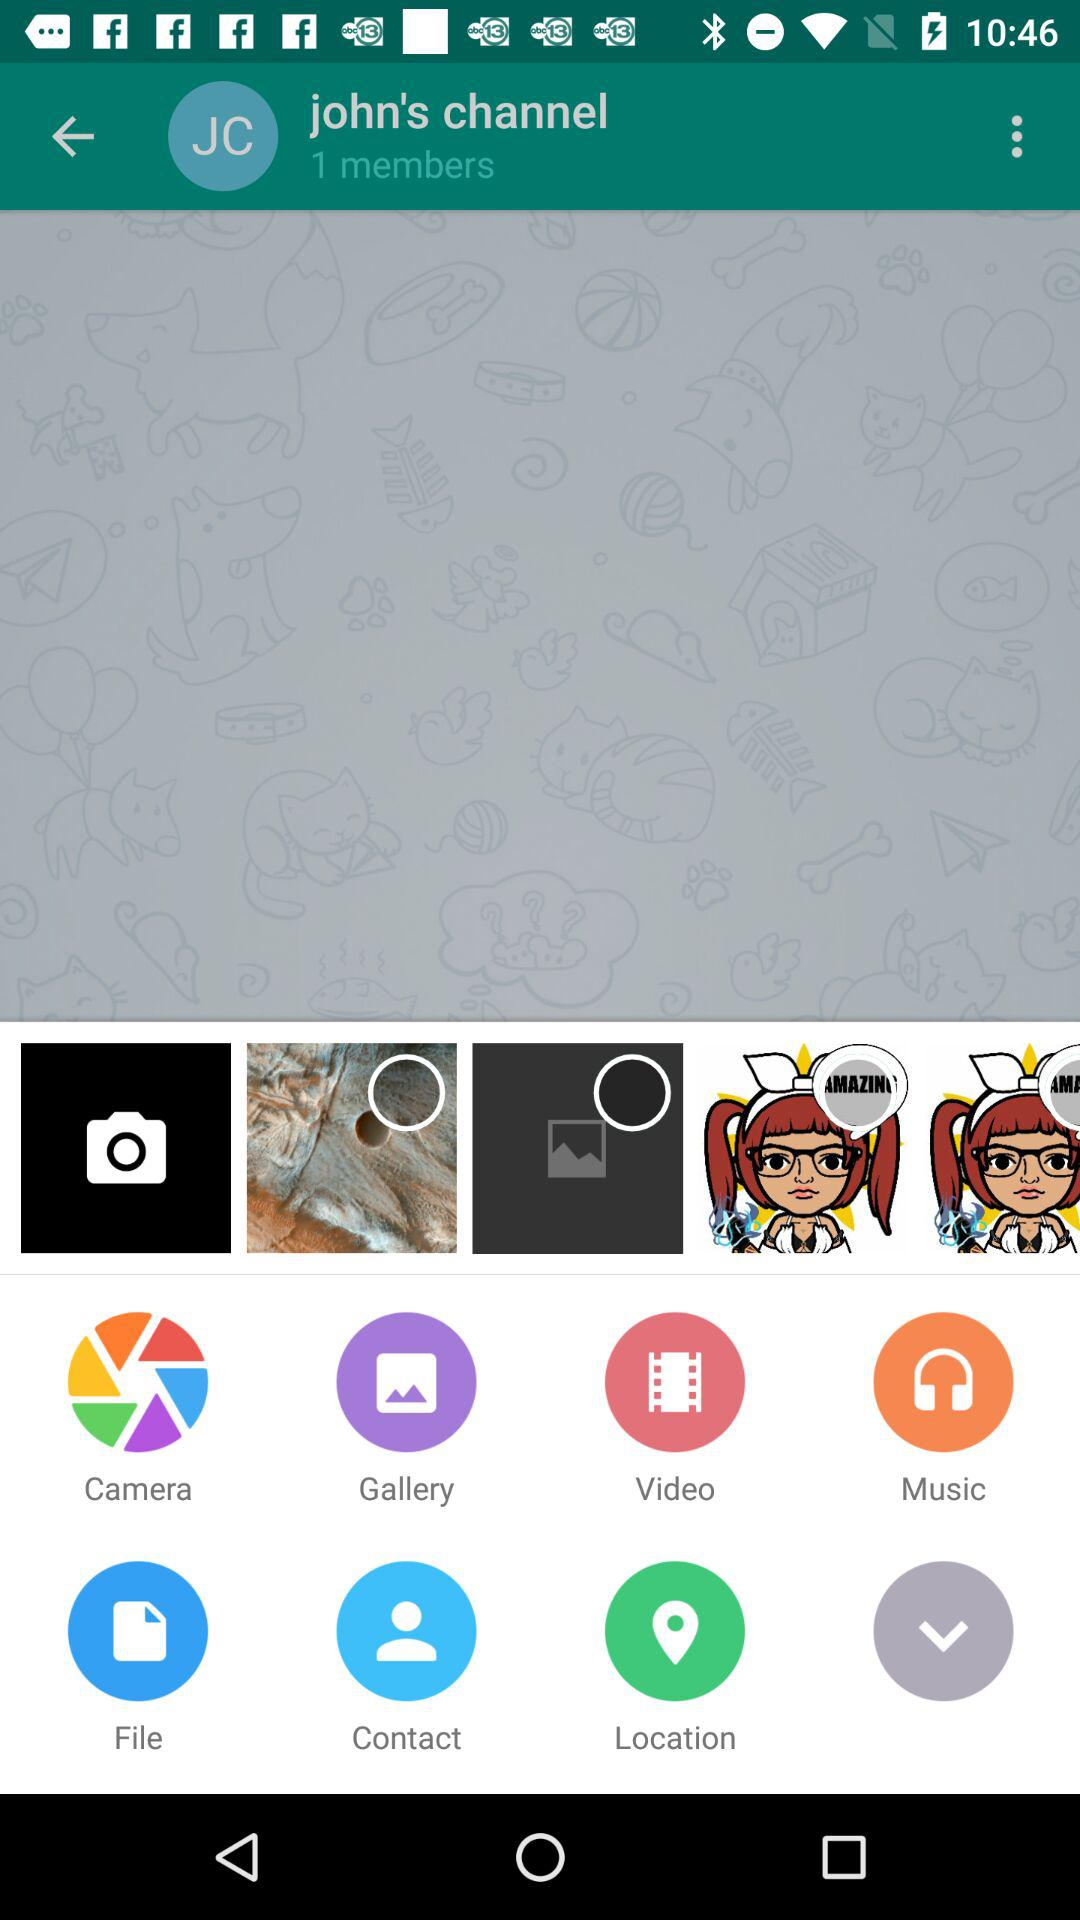What is the number of members? The number of members is 1. 